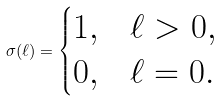Convert formula to latex. <formula><loc_0><loc_0><loc_500><loc_500>\sigma ( \ell ) = \begin{cases} 1 , & \ell > 0 , \\ 0 , & \ell = 0 . \end{cases}</formula> 